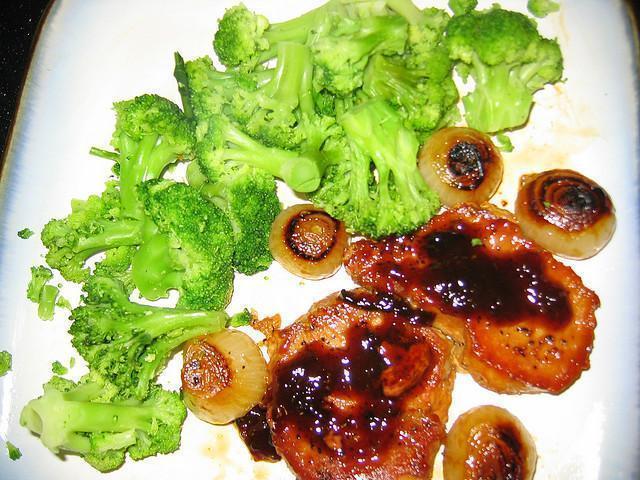What are the little round vegetables called?
Indicate the correct choice and explain in the format: 'Answer: answer
Rationale: rationale.'
Options: Brussels sprouts, tomatoes, turnip, onions. Answer: onions.
Rationale: The vegetables are the cooked version of a while root vegetable. 